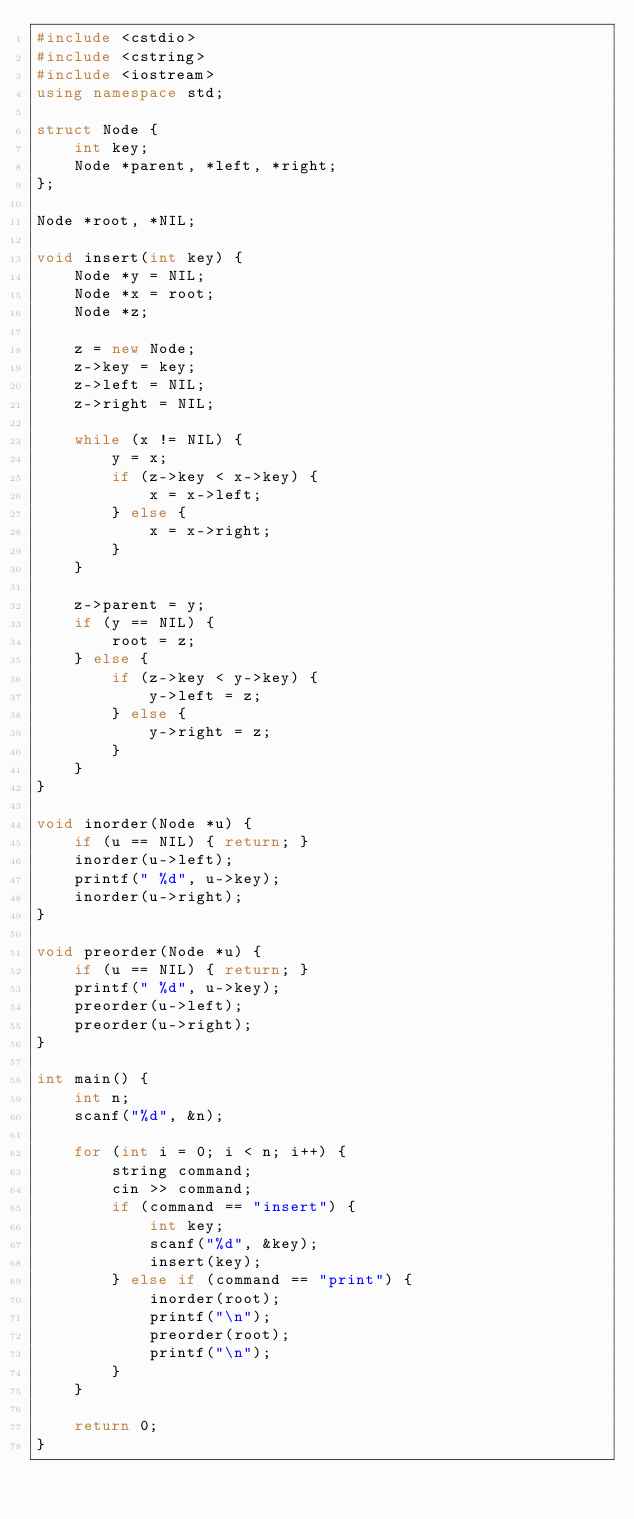Convert code to text. <code><loc_0><loc_0><loc_500><loc_500><_C++_>#include <cstdio>
#include <cstring>
#include <iostream>
using namespace std;

struct Node {
    int key;
    Node *parent, *left, *right;
};

Node *root, *NIL;

void insert(int key) {
    Node *y = NIL;
    Node *x = root;
    Node *z;

    z = new Node;
    z->key = key;
    z->left = NIL;
    z->right = NIL;

    while (x != NIL) {
        y = x;
        if (z->key < x->key) {
            x = x->left;
        } else {
            x = x->right;
        }
    }

    z->parent = y;
    if (y == NIL) {
        root = z;
    } else {
        if (z->key < y->key) {
            y->left = z;
        } else {
            y->right = z;
        }
    }
}

void inorder(Node *u) {
    if (u == NIL) { return; }
    inorder(u->left);
    printf(" %d", u->key);
    inorder(u->right);
}

void preorder(Node *u) {
    if (u == NIL) { return; }
    printf(" %d", u->key);
    preorder(u->left);
    preorder(u->right);
}

int main() {
    int n;
    scanf("%d", &n);

    for (int i = 0; i < n; i++) {
        string command;
        cin >> command;
        if (command == "insert") {
            int key;
            scanf("%d", &key);
            insert(key);
        } else if (command == "print") {
            inorder(root);
            printf("\n");
            preorder(root);
            printf("\n");
        }
    }

    return 0;
}
</code> 